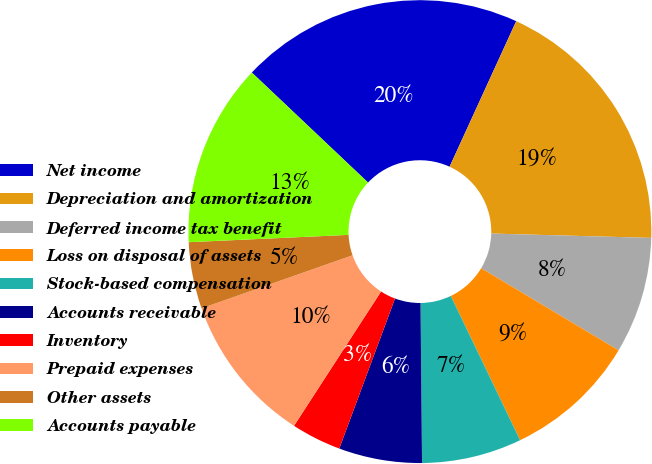Convert chart to OTSL. <chart><loc_0><loc_0><loc_500><loc_500><pie_chart><fcel>Net income<fcel>Depreciation and amortization<fcel>Deferred income tax benefit<fcel>Loss on disposal of assets<fcel>Stock-based compensation<fcel>Accounts receivable<fcel>Inventory<fcel>Prepaid expenses<fcel>Other assets<fcel>Accounts payable<nl><fcel>19.77%<fcel>18.6%<fcel>8.14%<fcel>9.3%<fcel>6.98%<fcel>5.81%<fcel>3.49%<fcel>10.47%<fcel>4.65%<fcel>12.79%<nl></chart> 